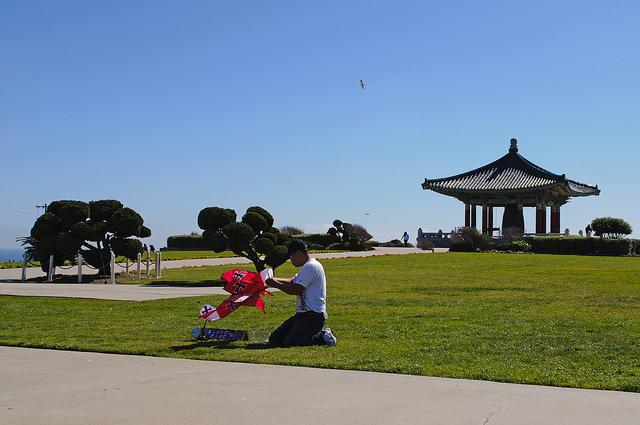What is the man kneeling going to do next? Please explain your reasoning. fly kite. The man is preparing the object. 